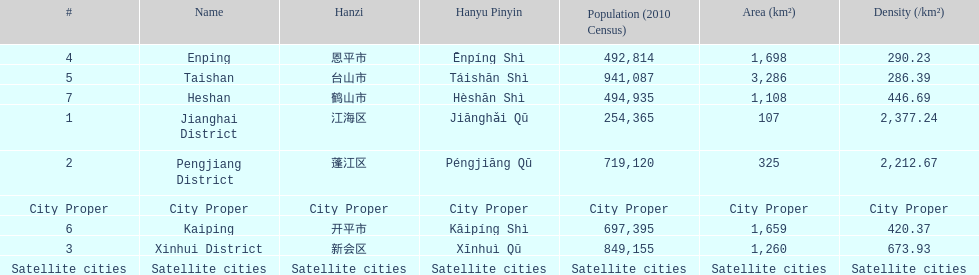Which area under the satellite cities has the most in population? Taishan. 